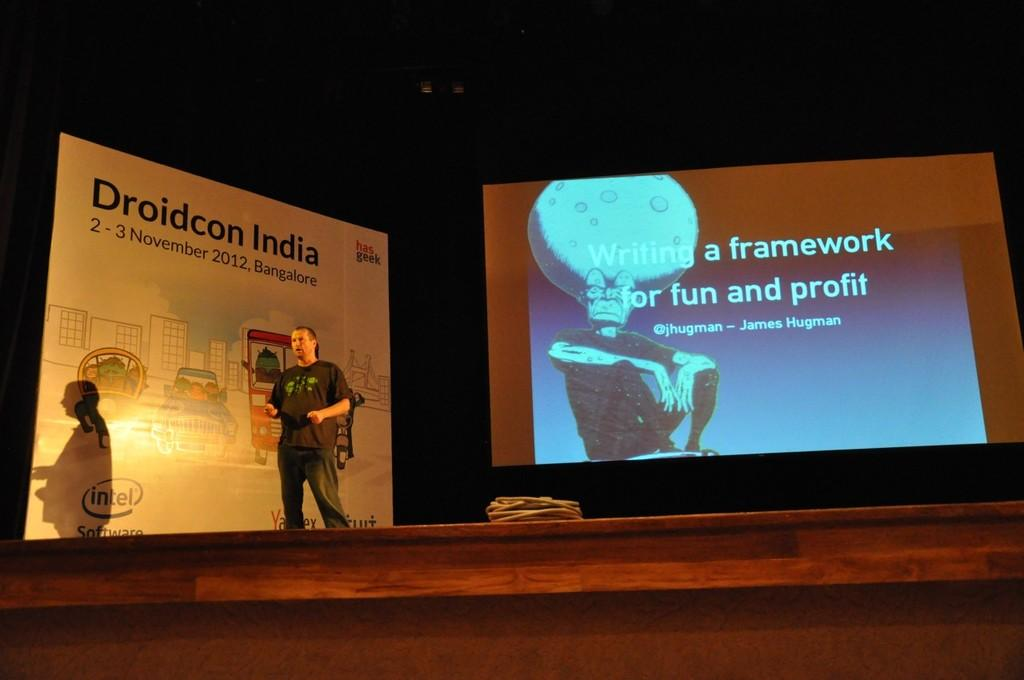What is the main object in the image? There is a screen in the image. What else can be seen in the image besides the screen? There is a banner in the image. Can you describe the person in the image? There is a person wearing a black color t-shirt in the image. What object is the person holding or carrying in the image? There is a bag in the image. How many sheep are visible in the image? There are no sheep present in the image. What type of medical advice can be obtained from the person in the image? The person in the image is not a doctor, so no medical advice can be obtained from them. 